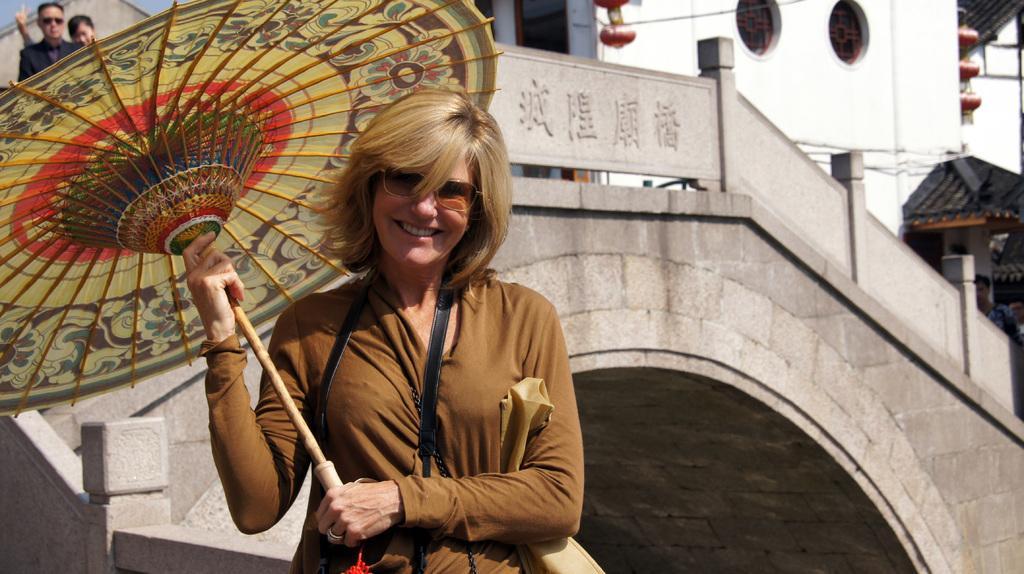Please provide a concise description of this image. In this image there is a woman with a smile on her face is holding an umbrella, behind the woman in the building there is a couple. 